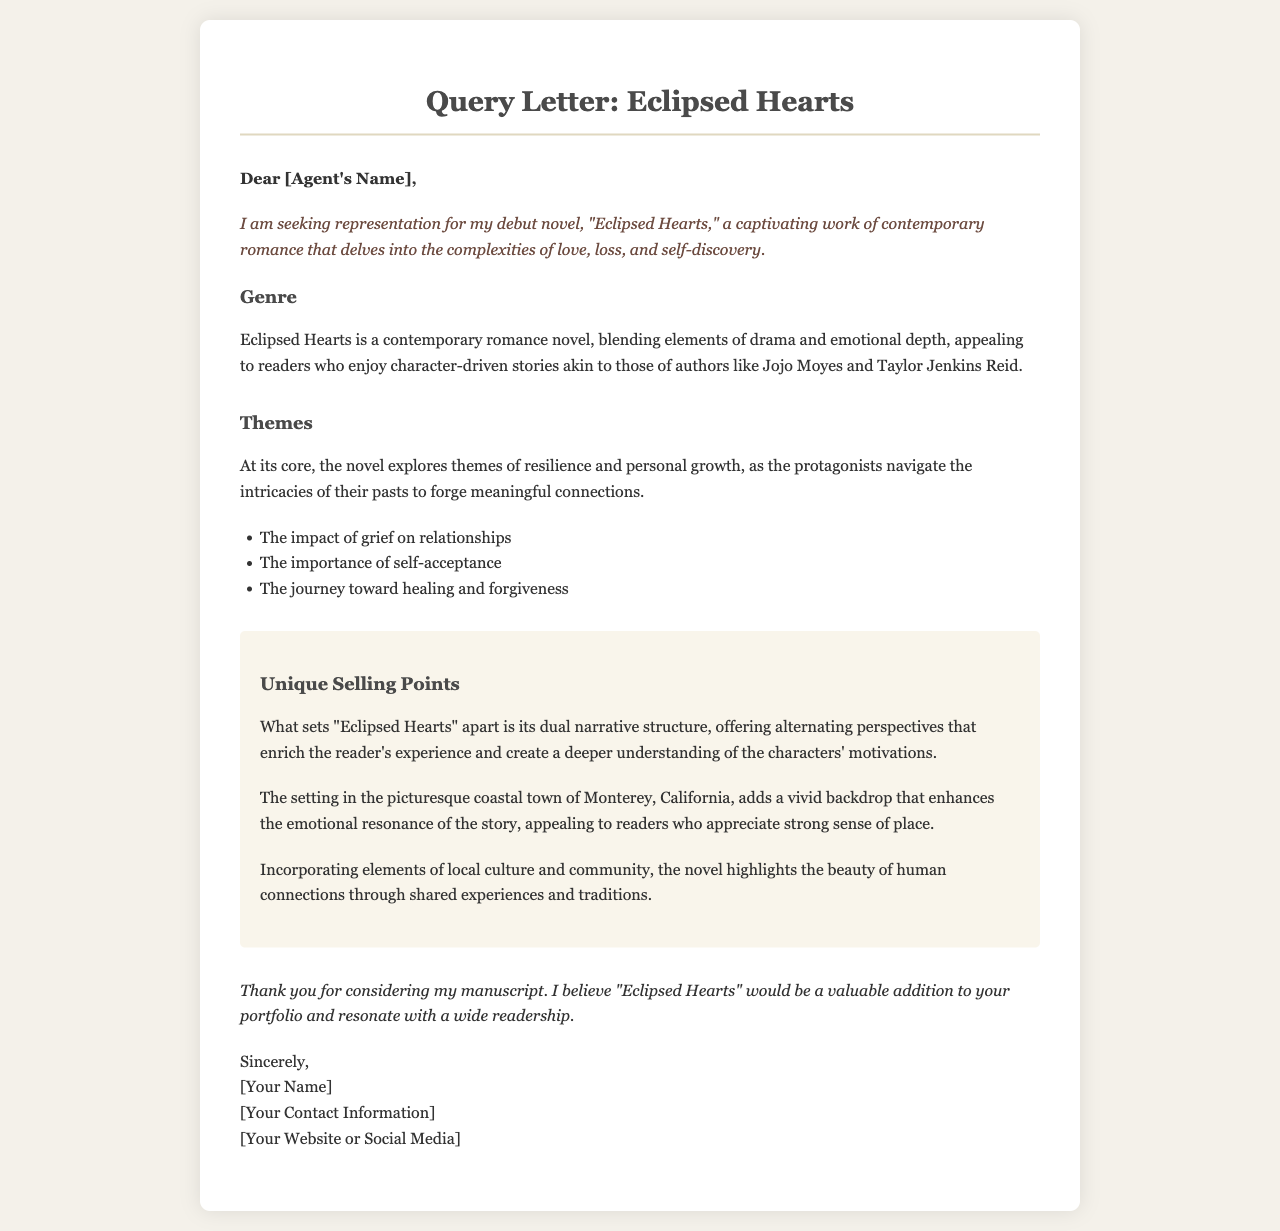What is the title of the manuscript? The title of the manuscript is mentioned in the opening paragraph of the letter.
Answer: Eclipsed Hearts Who is the intended audience for the novel? The intended audience is referenced in the genre section, relating it to readers of specific authors.
Answer: Readers who enjoy character-driven stories What themes are explored in "Eclipsed Hearts"? The themes are listed in the section specifically discussing themes, including three key points.
Answer: Resilience and personal growth What is one unique selling point of the novel? A unique selling point is provided in the unique points section, which highlights a specific storytelling technique.
Answer: Dual narrative structure Where is the setting of the novel? The setting details are included in the unique selling points section, describing the location's charm.
Answer: Monterey, California What key emotional aspect does the novel address? The emotional aspect is discussed in relation to the themes, focusing on profound personal experiences.
Answer: Grief What does the author seek in the letter? The author's purpose is outlined in the opening paragraph of the letter.
Answer: Representation Who is the author reaching out to? The author mentions the recipient of the letter at the top, specifying the relationship sought.
Answer: Literary agent 